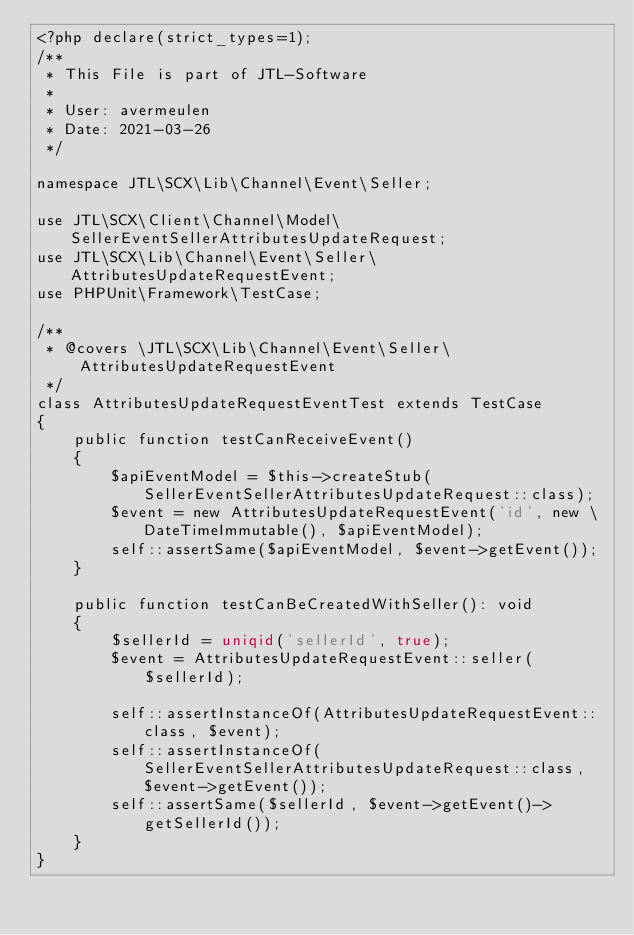Convert code to text. <code><loc_0><loc_0><loc_500><loc_500><_PHP_><?php declare(strict_types=1);
/**
 * This File is part of JTL-Software
 *
 * User: avermeulen
 * Date: 2021-03-26
 */

namespace JTL\SCX\Lib\Channel\Event\Seller;

use JTL\SCX\Client\Channel\Model\SellerEventSellerAttributesUpdateRequest;
use JTL\SCX\Lib\Channel\Event\Seller\AttributesUpdateRequestEvent;
use PHPUnit\Framework\TestCase;

/**
 * @covers \JTL\SCX\Lib\Channel\Event\Seller\AttributesUpdateRequestEvent
 */
class AttributesUpdateRequestEventTest extends TestCase
{
    public function testCanReceiveEvent()
    {
        $apiEventModel = $this->createStub(SellerEventSellerAttributesUpdateRequest::class);
        $event = new AttributesUpdateRequestEvent('id', new \DateTimeImmutable(), $apiEventModel);
        self::assertSame($apiEventModel, $event->getEvent());
    }

    public function testCanBeCreatedWithSeller(): void
    {
        $sellerId = uniqid('sellerId', true);
        $event = AttributesUpdateRequestEvent::seller($sellerId);

        self::assertInstanceOf(AttributesUpdateRequestEvent::class, $event);
        self::assertInstanceOf(SellerEventSellerAttributesUpdateRequest::class, $event->getEvent());
        self::assertSame($sellerId, $event->getEvent()->getSellerId());
    }
}
</code> 